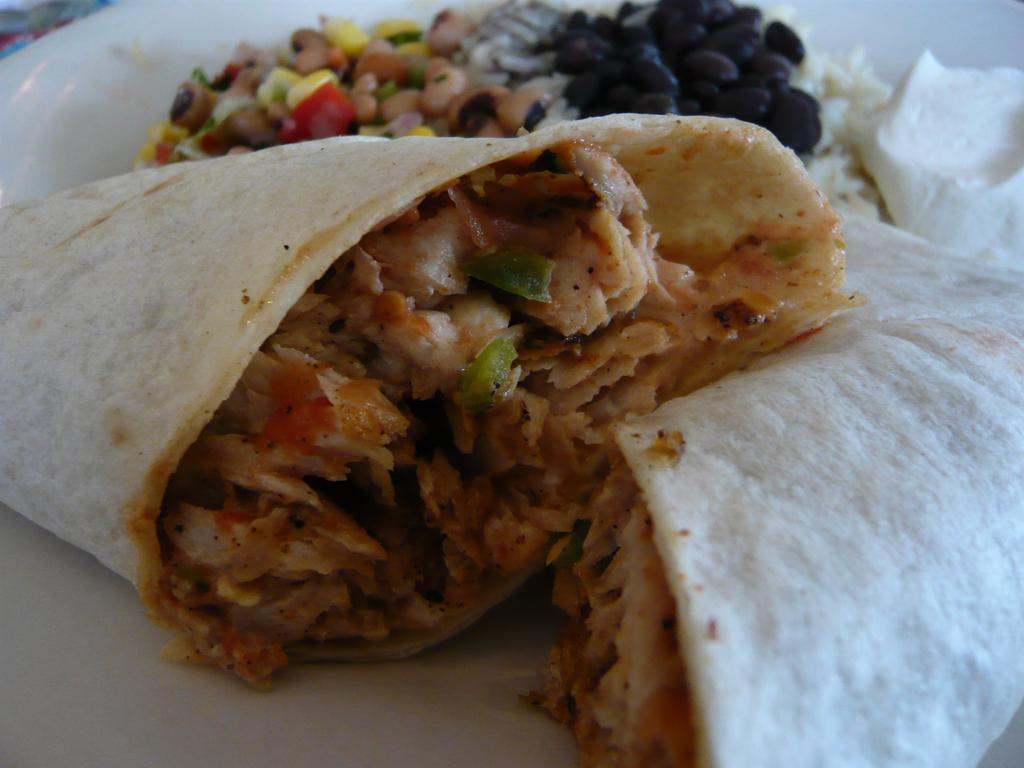What types of items can be seen in the image? There are food items in the image. What is the color of the plate on which the food items are placed? The plate is white in color. What type of umbrella is being used to protect the food items from the rain in the image? There is no umbrella present in the image, and the food items are not being protected from the rain. 